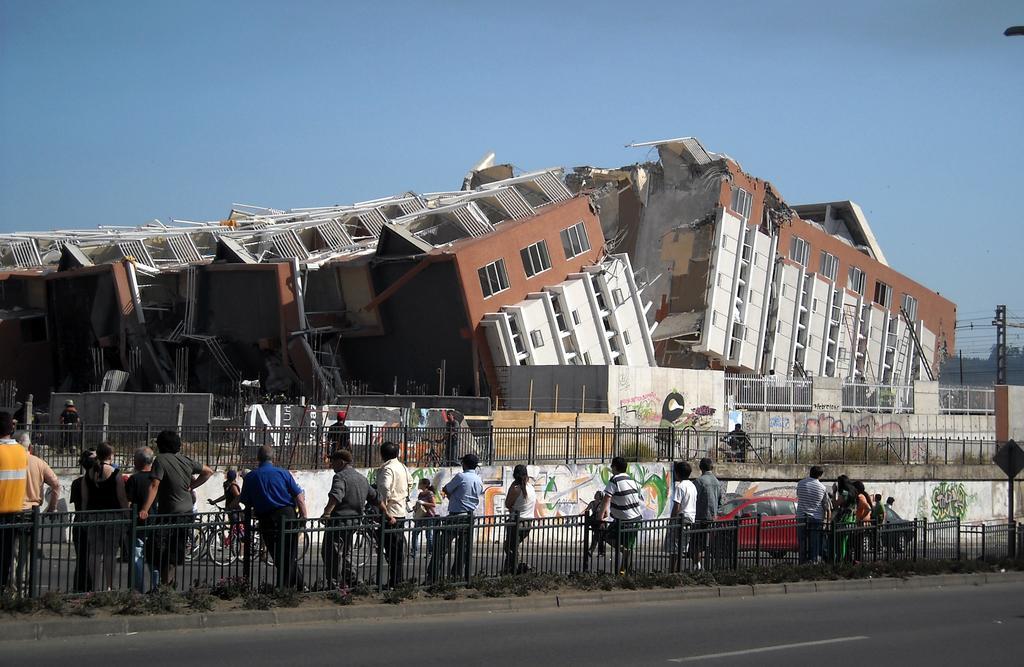Could you give a brief overview of what you see in this image? Here we a collapsed building, people, fence, cars, bicycles and signboard. Far there is a pole and trees. Background there is a sky. Graffiti is on the wall. 